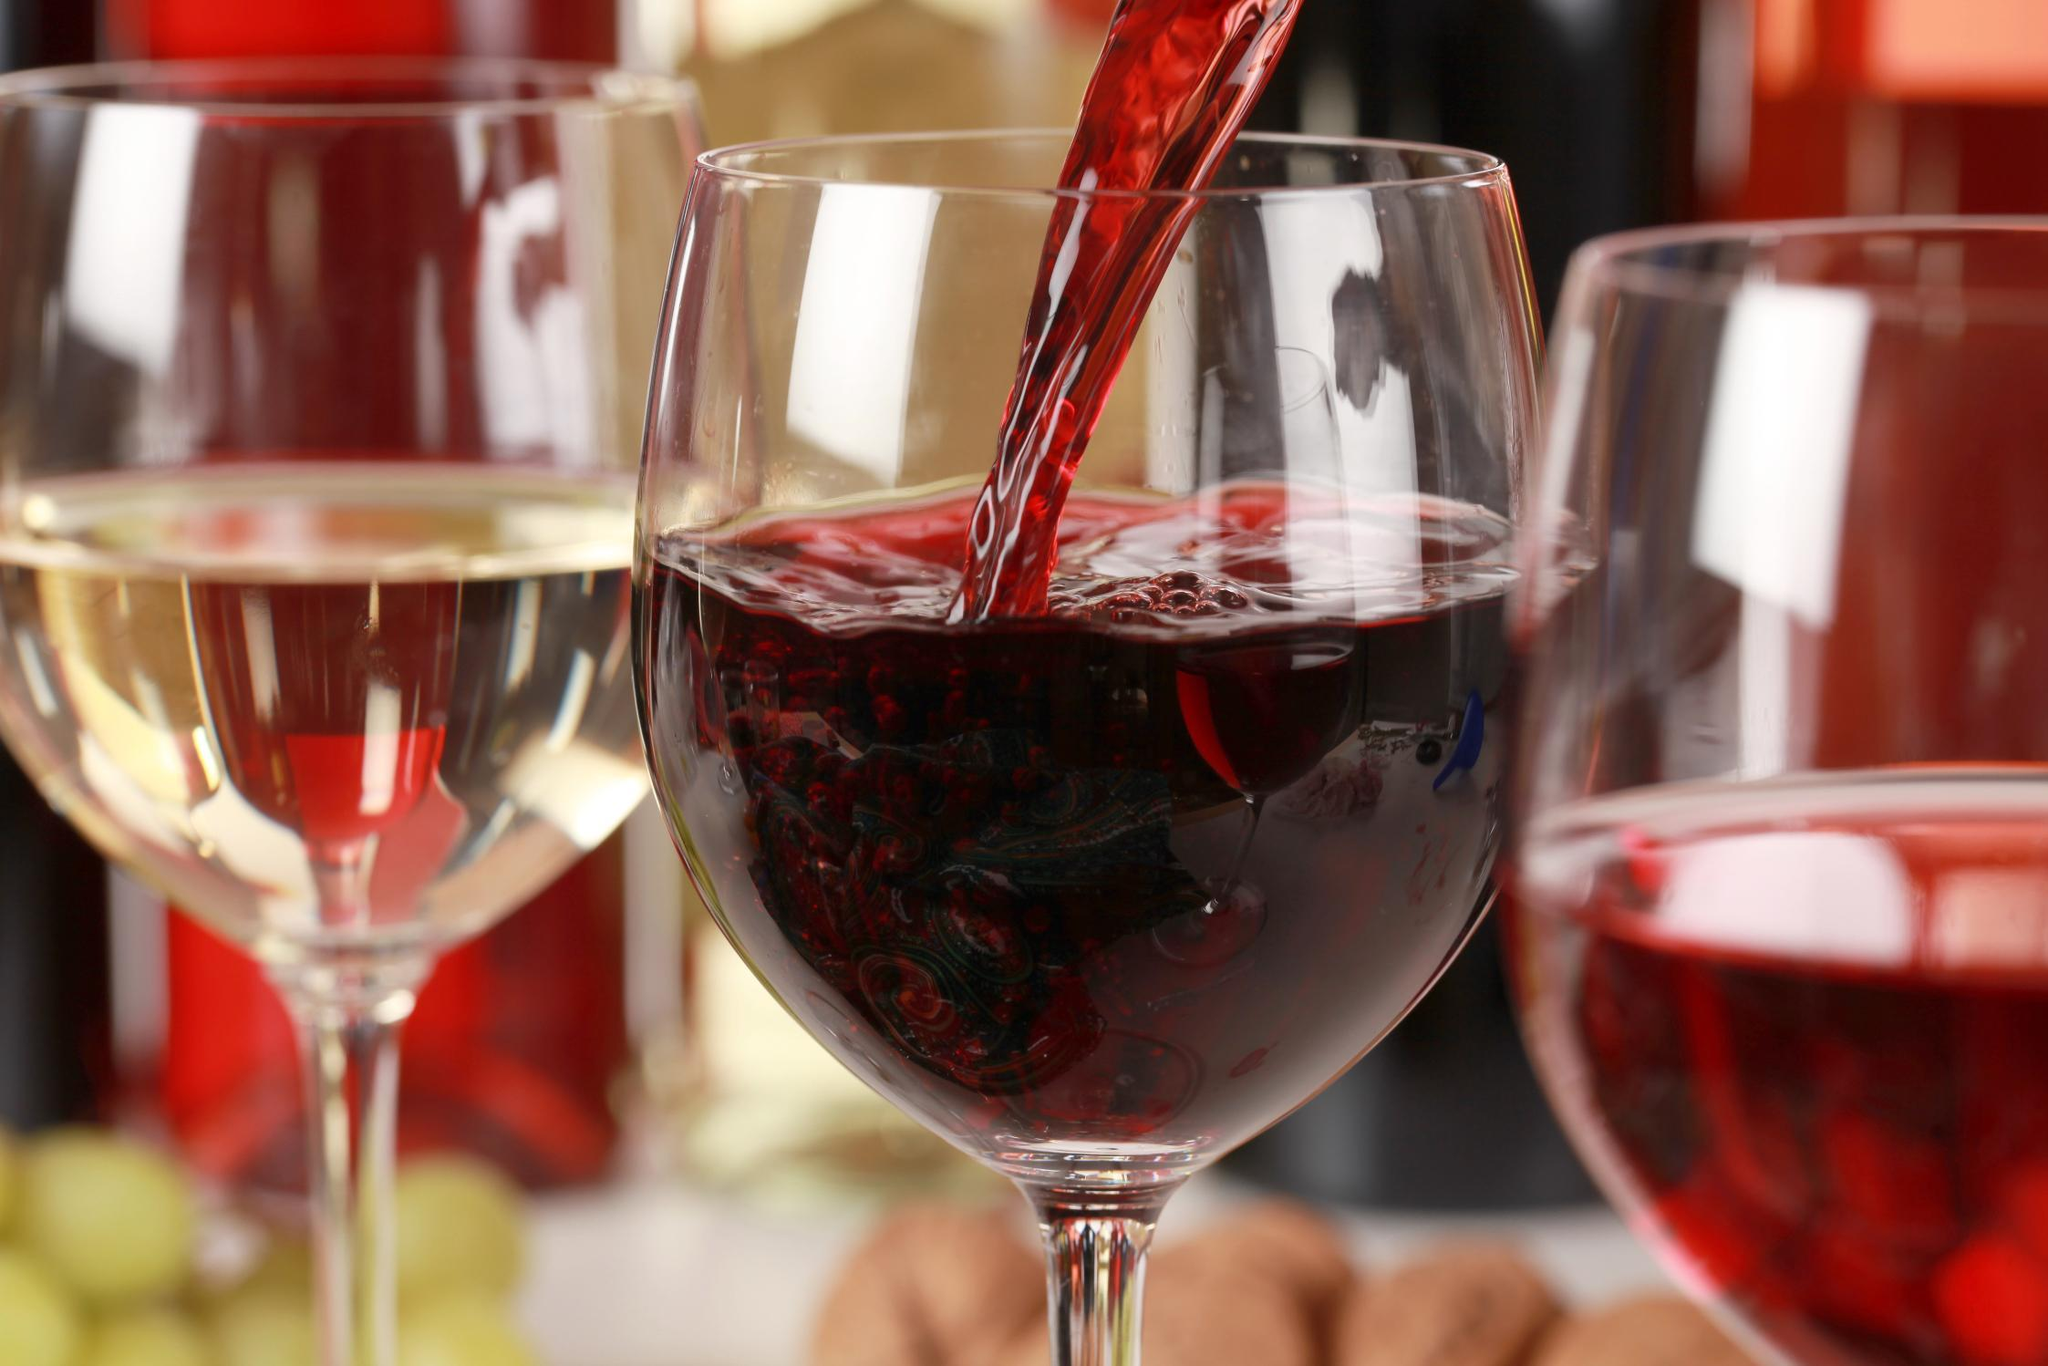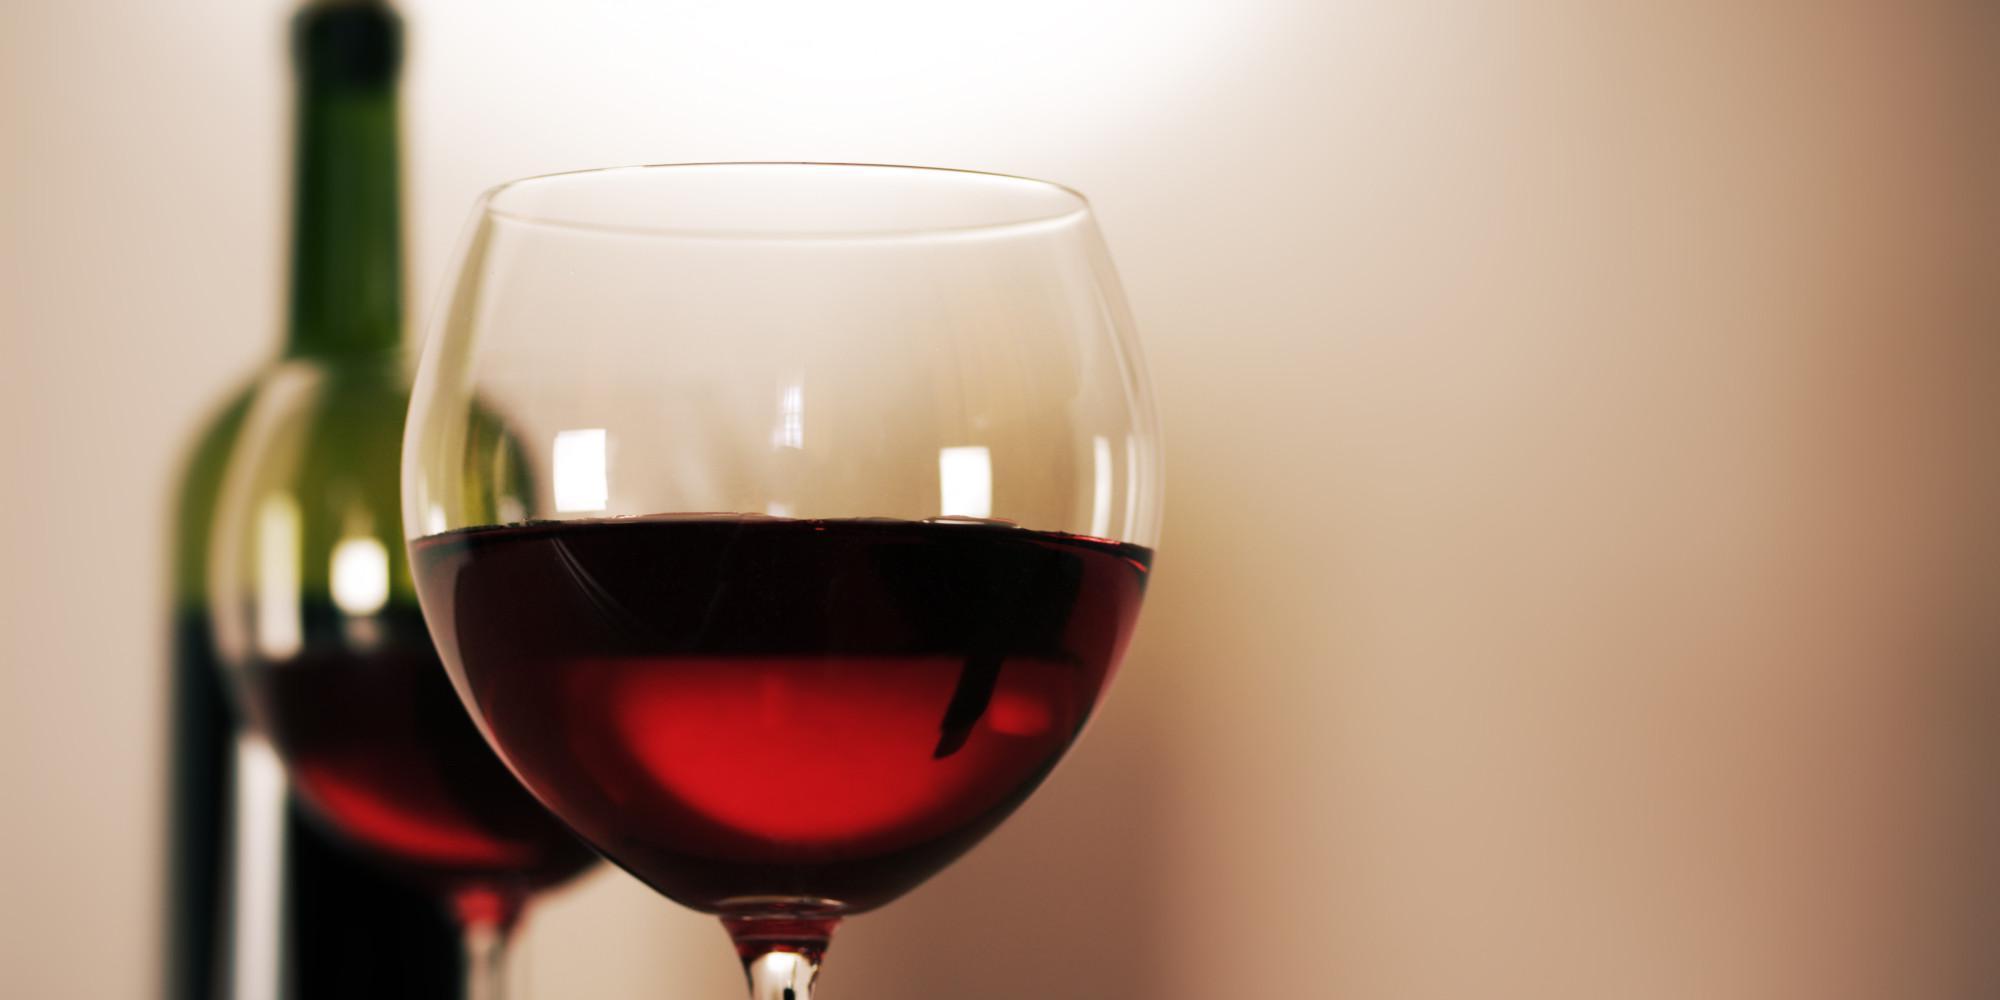The first image is the image on the left, the second image is the image on the right. Examine the images to the left and right. Is the description "One of the images contains exactly two glasses of wine." accurate? Answer yes or no. Yes. 